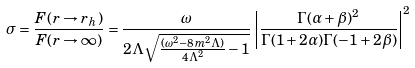Convert formula to latex. <formula><loc_0><loc_0><loc_500><loc_500>\sigma = \frac { F ( r \rightarrow r _ { h } ) } { F ( r \rightarrow \infty ) } = \frac { \omega } { 2 \Lambda \sqrt { \frac { ( \omega ^ { 2 } - 8 m ^ { 2 } \Lambda ) } { 4 \Lambda ^ { 2 } } - 1 } } \left | \frac { \Gamma ( \alpha + \beta ) ^ { 2 } } { \Gamma ( 1 + 2 \alpha ) \Gamma ( - 1 + 2 \beta ) } \right | ^ { 2 }</formula> 